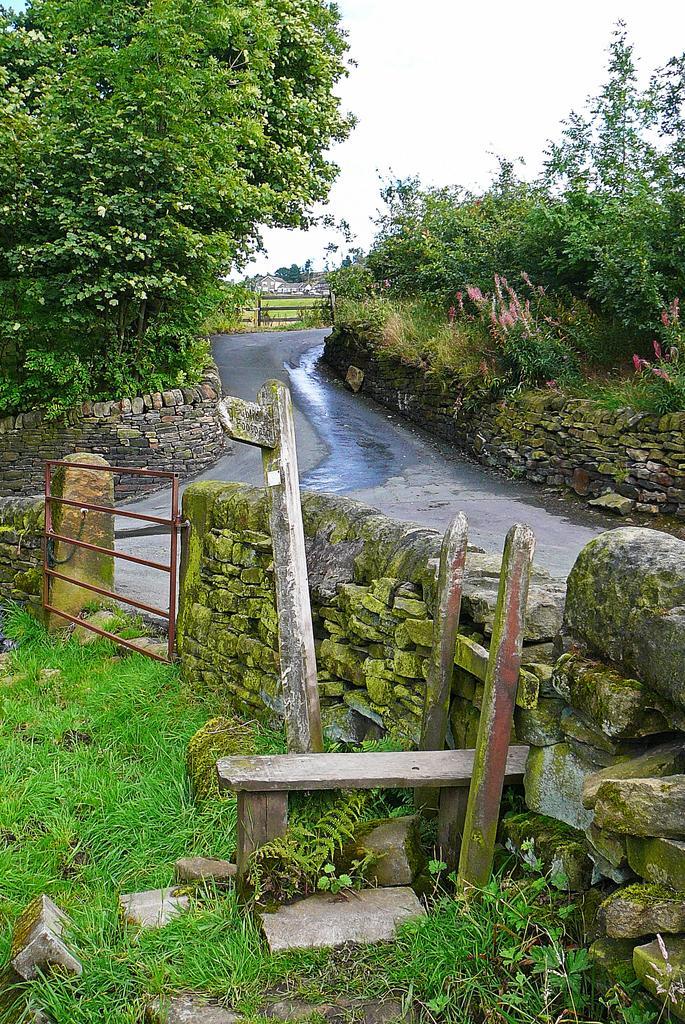Could you give a brief overview of what you see in this image? At the bottom we can see wall,gate,stones,wooden objects and grass on the ground. In the background there is a road and to either side of the road there are trees,fence,field,houses and sky. 